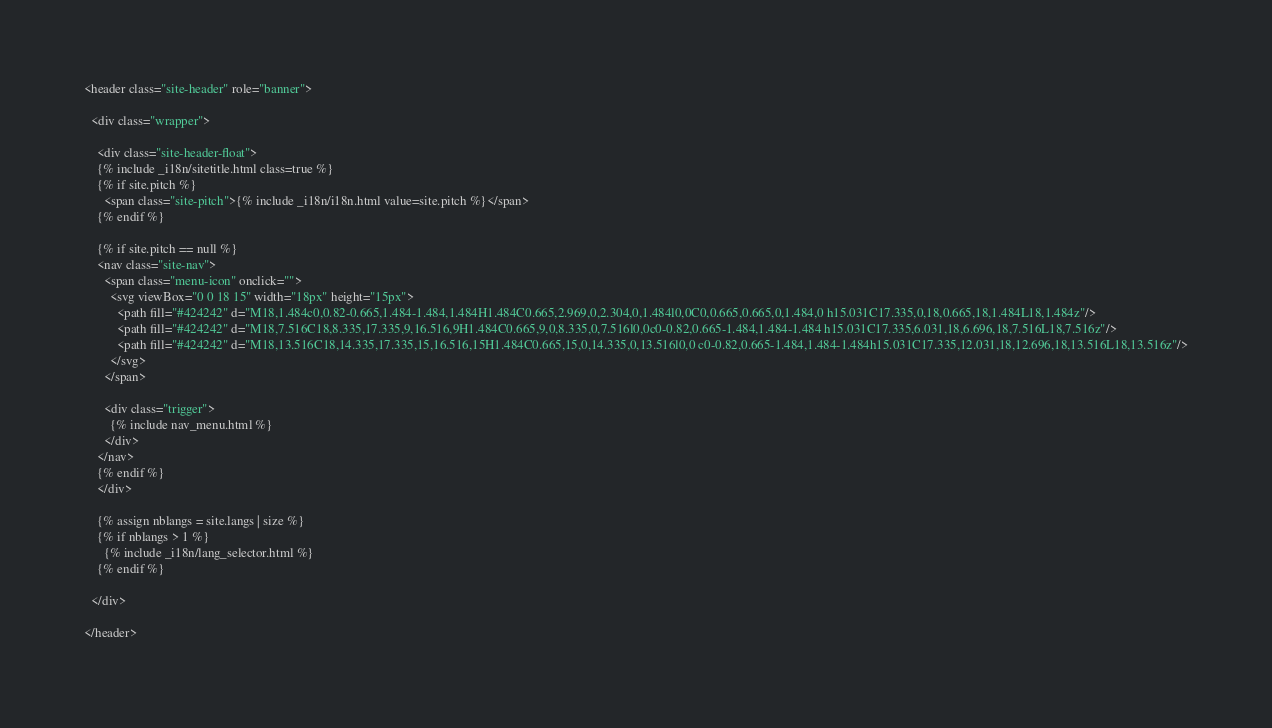Convert code to text. <code><loc_0><loc_0><loc_500><loc_500><_HTML_><header class="site-header" role="banner">

  <div class="wrapper">

    <div class="site-header-float">
    {% include _i18n/sitetitle.html class=true %}
    {% if site.pitch %}
      <span class="site-pitch">{% include _i18n/i18n.html value=site.pitch %}</span>
    {% endif %}

    {% if site.pitch == null %}
    <nav class="site-nav">
      <span class="menu-icon" onclick="">
        <svg viewBox="0 0 18 15" width="18px" height="15px">
          <path fill="#424242" d="M18,1.484c0,0.82-0.665,1.484-1.484,1.484H1.484C0.665,2.969,0,2.304,0,1.484l0,0C0,0.665,0.665,0,1.484,0 h15.031C17.335,0,18,0.665,18,1.484L18,1.484z"/>
          <path fill="#424242" d="M18,7.516C18,8.335,17.335,9,16.516,9H1.484C0.665,9,0,8.335,0,7.516l0,0c0-0.82,0.665-1.484,1.484-1.484 h15.031C17.335,6.031,18,6.696,18,7.516L18,7.516z"/>
          <path fill="#424242" d="M18,13.516C18,14.335,17.335,15,16.516,15H1.484C0.665,15,0,14.335,0,13.516l0,0 c0-0.82,0.665-1.484,1.484-1.484h15.031C17.335,12.031,18,12.696,18,13.516L18,13.516z"/>
        </svg>
      </span>

      <div class="trigger">
        {% include nav_menu.html %}
      </div>
    </nav>
    {% endif %}
    </div>

    {% assign nblangs = site.langs | size %}
    {% if nblangs > 1 %}
      {% include _i18n/lang_selector.html %}
    {% endif %}

  </div>

</header>
</code> 